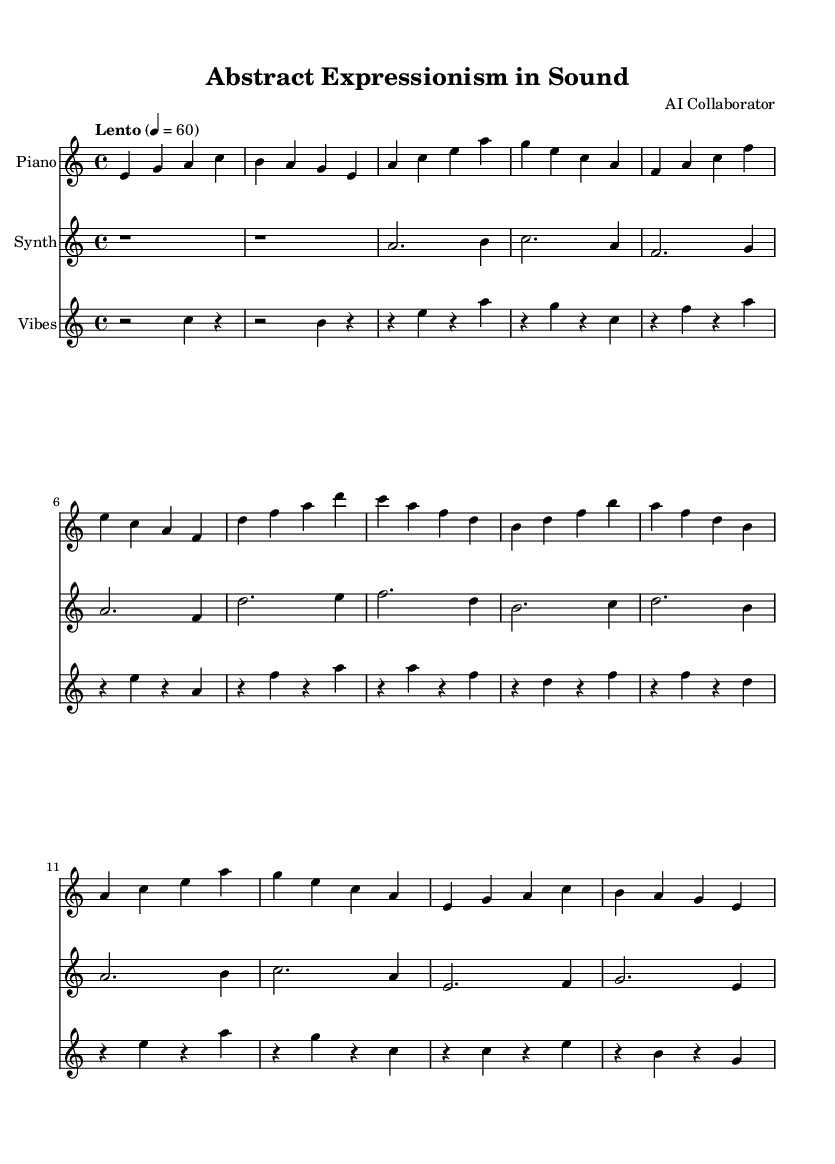What is the key signature of this music? The key signature shown at the beginning of the score indicates it is in A minor, which has no sharps or flats.
Answer: A minor What is the time signature of this piece? The time signature indicated at the beginning of the score is 4/4, meaning there are four beats in each measure.
Answer: 4/4 What is the tempo marking given for this composition? The tempo marking at the top of the score is "Lento," which instructs the performer to play slowly, at a tempo of 60 beats per minute.
Answer: Lento How many different instruments are featured in the score? The score contains parts for three different instruments: piano, synthesizer, and vibraphone.
Answer: Three Which instrument has the highest pitch range? By analyzing the notes written for each instrument, the synthesizer part generally contains higher pitches than the piano and vibraphone, indicating it has the highest pitch range.
Answer: Synthesizer In what style is the piece composed, as suggested by its title? The title "Abstract Expressionism in Sound" implies that the piece is composed in a way that reflects the principles of abstract expressionism, focusing on spontaneous emotion and free-form creativity.
Answer: Abstract Expressionism What type of music piece is this classified as? Given the ambient nature of the music and the use of instrumental texture over melody, it can be classified as ambient instrumental music.
Answer: Ambient instrumental 